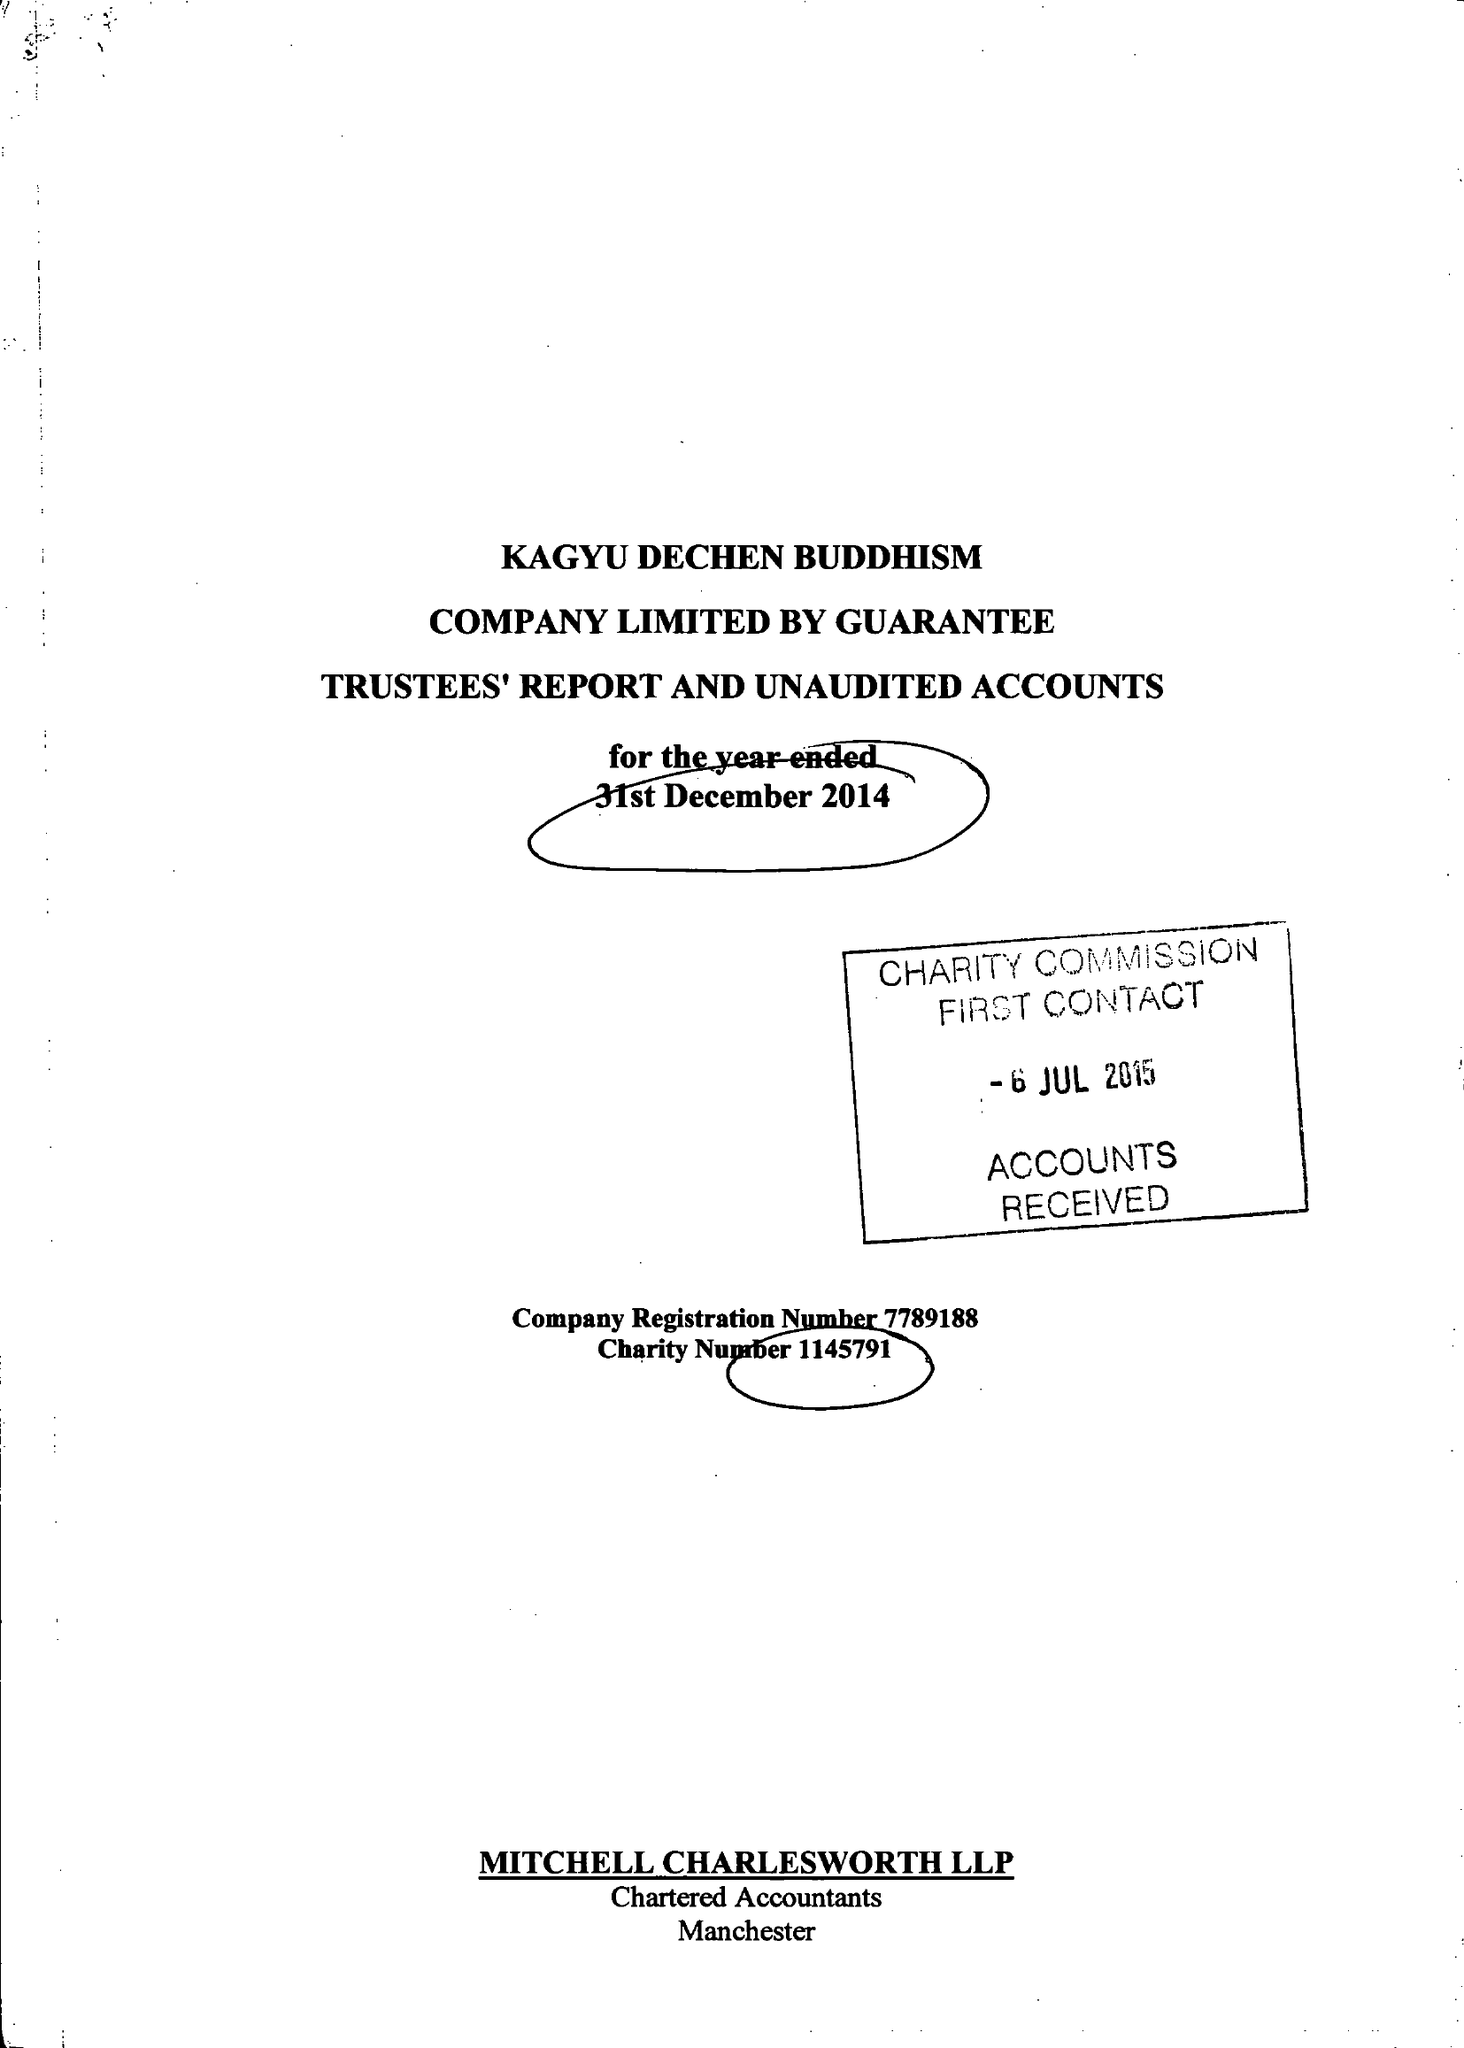What is the value for the spending_annually_in_british_pounds?
Answer the question using a single word or phrase. 117014.00 